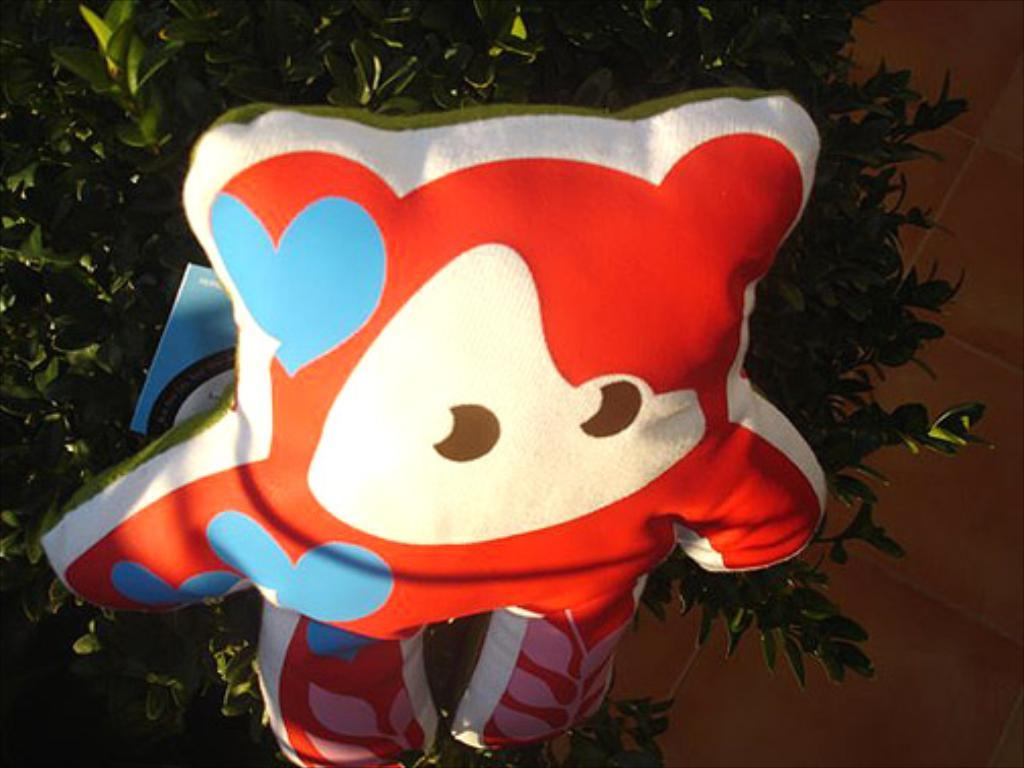What is the main object in the image? There is a balloon in the image. What can be seen in the background of the image? There are trees and a wall in the background of the image. What type of marble is used to decorate the wall in the image? There is no marble visible in the image; the wall is not described in detail. 